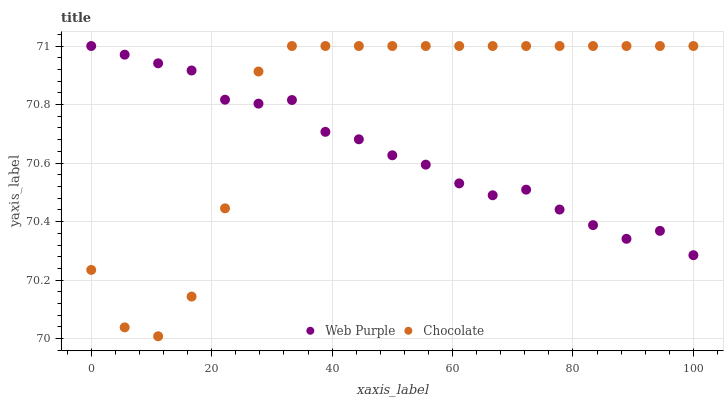Does Web Purple have the minimum area under the curve?
Answer yes or no. Yes. Does Chocolate have the maximum area under the curve?
Answer yes or no. Yes. Does Chocolate have the minimum area under the curve?
Answer yes or no. No. Is Web Purple the smoothest?
Answer yes or no. Yes. Is Chocolate the roughest?
Answer yes or no. Yes. Is Chocolate the smoothest?
Answer yes or no. No. Does Chocolate have the lowest value?
Answer yes or no. Yes. Does Chocolate have the highest value?
Answer yes or no. Yes. Does Web Purple intersect Chocolate?
Answer yes or no. Yes. Is Web Purple less than Chocolate?
Answer yes or no. No. Is Web Purple greater than Chocolate?
Answer yes or no. No. 